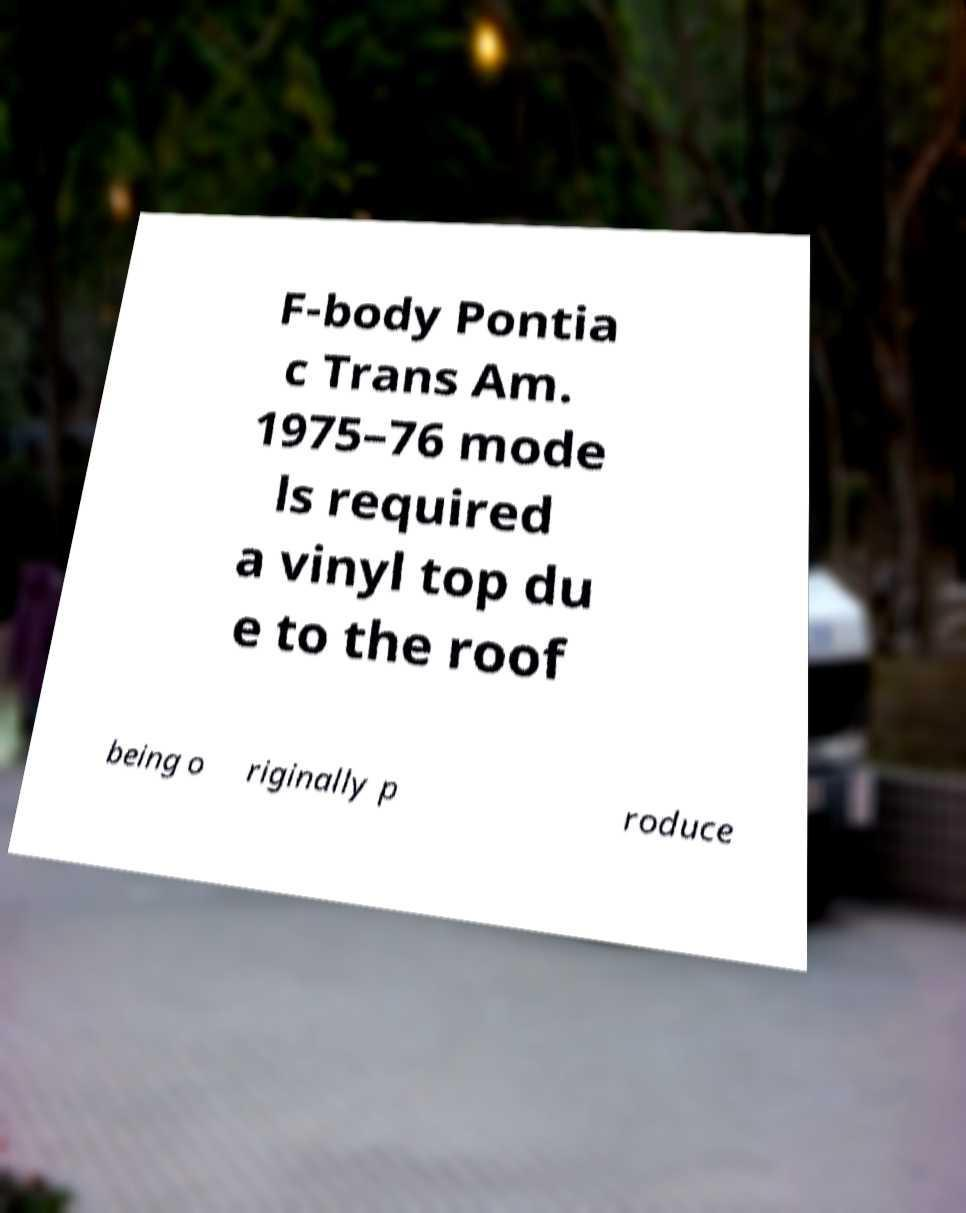I need the written content from this picture converted into text. Can you do that? F-body Pontia c Trans Am. 1975–76 mode ls required a vinyl top du e to the roof being o riginally p roduce 